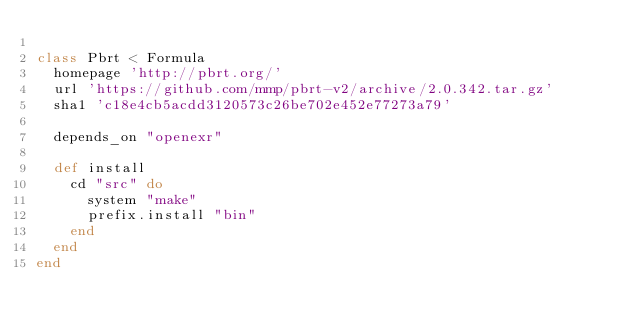<code> <loc_0><loc_0><loc_500><loc_500><_Ruby_>
class Pbrt < Formula
  homepage 'http://pbrt.org/'
  url 'https://github.com/mmp/pbrt-v2/archive/2.0.342.tar.gz'
  sha1 'c18e4cb5acdd3120573c26be702e452e77273a79'

  depends_on "openexr"

  def install
    cd "src" do
      system "make"
      prefix.install "bin"
    end
  end
end
</code> 